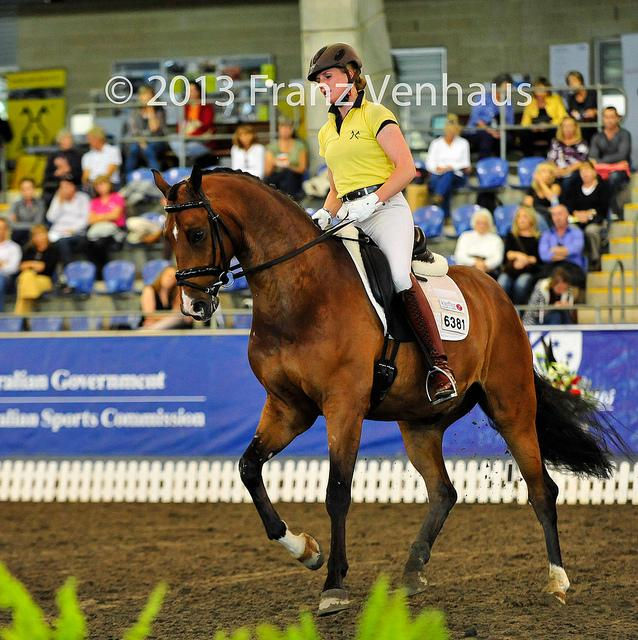What is the woman in yellow doing on the horse? riding 